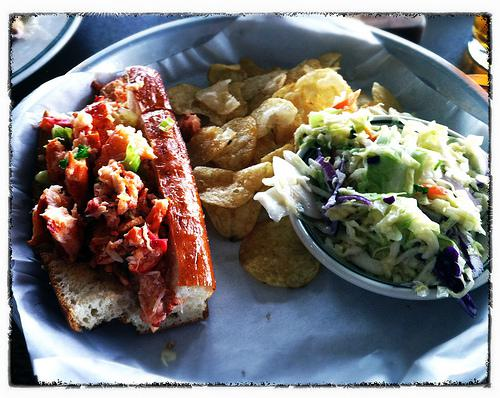Question: who is present?
Choices:
A. No one.
B. Nobody.
C. The entire class.
D. The instructor.
Answer with the letter. Answer: B Question: what is present?
Choices:
A. Drink.
B. Food.
C. Tables.
D. Gifts.
Answer with the letter. Answer: B Question: what is it for?
Choices:
A. Wearing.
B. Decoration.
C. Utilization.
D. Eating.
Answer with the letter. Answer: D 